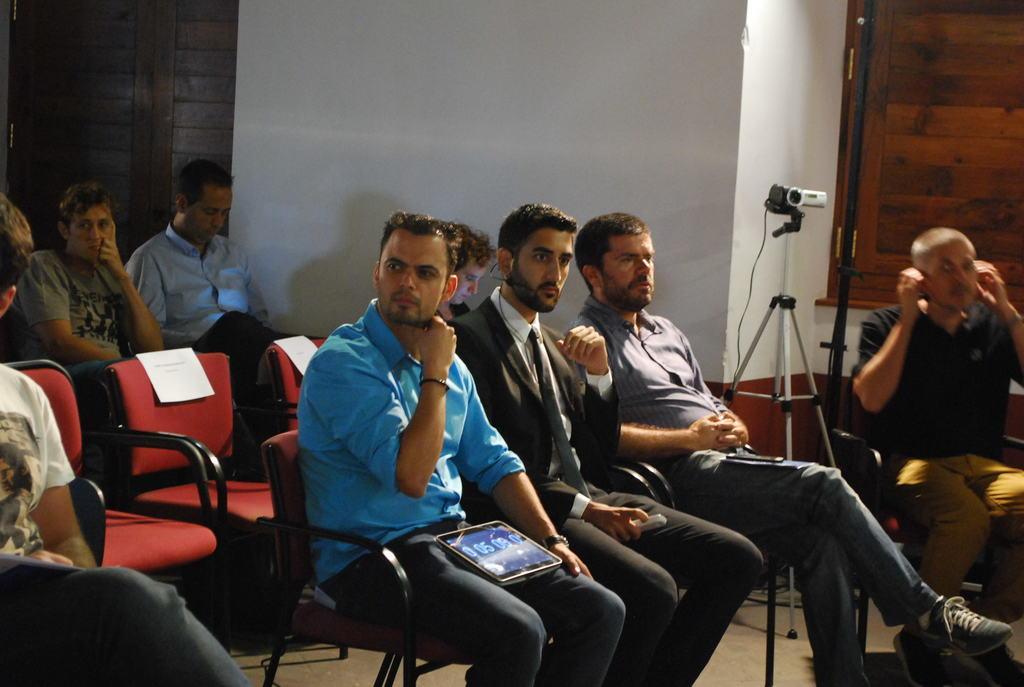Can you describe this image briefly? In this image i can see group of people sitting on chair, i can see a tablet in a lap of a person. In the background i can see a wall and a camera. 